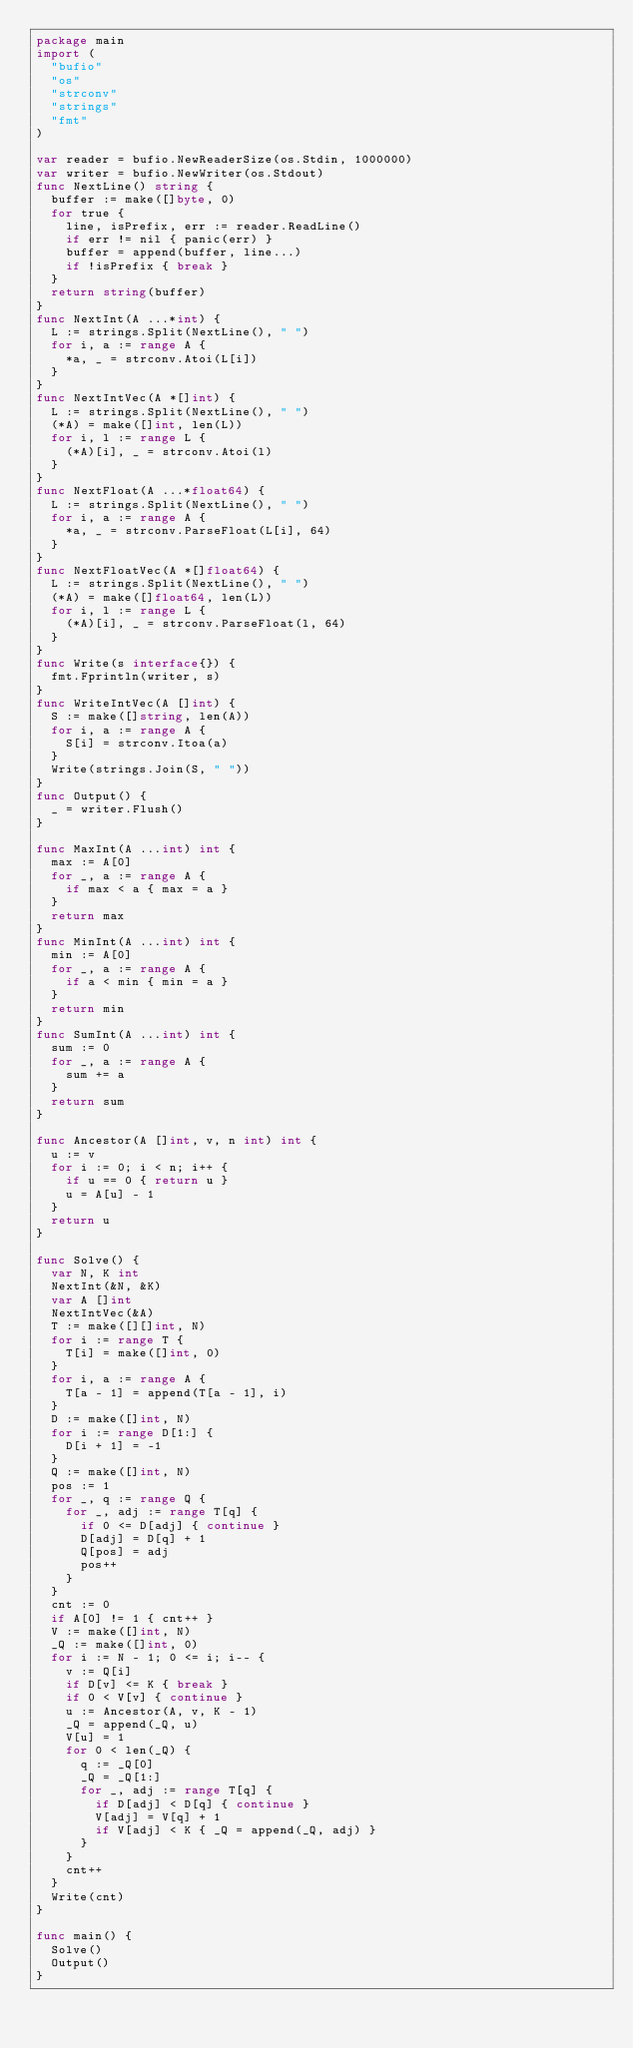<code> <loc_0><loc_0><loc_500><loc_500><_Go_>package main
import (
  "bufio"
  "os"
  "strconv"
  "strings"
  "fmt"
)

var reader = bufio.NewReaderSize(os.Stdin, 1000000)
var writer = bufio.NewWriter(os.Stdout)
func NextLine() string {
  buffer := make([]byte, 0)
  for true {
    line, isPrefix, err := reader.ReadLine()
    if err != nil { panic(err) }
    buffer = append(buffer, line...)
    if !isPrefix { break }
  }
  return string(buffer)
}
func NextInt(A ...*int) {
  L := strings.Split(NextLine(), " ")
  for i, a := range A {
    *a, _ = strconv.Atoi(L[i])
  }
}
func NextIntVec(A *[]int) {
  L := strings.Split(NextLine(), " ")
  (*A) = make([]int, len(L))
  for i, l := range L {
    (*A)[i], _ = strconv.Atoi(l)
  }
}
func NextFloat(A ...*float64) {
  L := strings.Split(NextLine(), " ")
  for i, a := range A {
    *a, _ = strconv.ParseFloat(L[i], 64)
  }
}
func NextFloatVec(A *[]float64) {
  L := strings.Split(NextLine(), " ")
  (*A) = make([]float64, len(L))
  for i, l := range L {
    (*A)[i], _ = strconv.ParseFloat(l, 64)
  }
}
func Write(s interface{}) {
  fmt.Fprintln(writer, s)
}
func WriteIntVec(A []int) {
  S := make([]string, len(A))
  for i, a := range A {
    S[i] = strconv.Itoa(a)
  }
  Write(strings.Join(S, " "))
}
func Output() {
  _ = writer.Flush()
}

func MaxInt(A ...int) int {
  max := A[0]
  for _, a := range A {
    if max < a { max = a }
  }
  return max
}
func MinInt(A ...int) int {
  min := A[0]
  for _, a := range A {
    if a < min { min = a }
  }
  return min
}
func SumInt(A ...int) int {
  sum := 0
  for _, a := range A {
    sum += a
  }
  return sum
}

func Ancestor(A []int, v, n int) int {
  u := v
  for i := 0; i < n; i++ {
    if u == 0 { return u }
    u = A[u] - 1
  }
  return u
}

func Solve() {
  var N, K int
  NextInt(&N, &K)
  var A []int
  NextIntVec(&A)
  T := make([][]int, N)
  for i := range T {
    T[i] = make([]int, 0)
  }
  for i, a := range A {
    T[a - 1] = append(T[a - 1], i)
  }
  D := make([]int, N)
  for i := range D[1:] {
    D[i + 1] = -1
  }
  Q := make([]int, N)
  pos := 1
  for _, q := range Q {
    for _, adj := range T[q] {
      if 0 <= D[adj] { continue }
      D[adj] = D[q] + 1
      Q[pos] = adj
      pos++
    }
  }
  cnt := 0
  if A[0] != 1 { cnt++ }
  V := make([]int, N)
  _Q := make([]int, 0)
  for i := N - 1; 0 <= i; i-- {
    v := Q[i]
    if D[v] <= K { break }
    if 0 < V[v] { continue }
    u := Ancestor(A, v, K - 1)
    _Q = append(_Q, u)
    V[u] = 1
    for 0 < len(_Q) {
      q := _Q[0]
      _Q = _Q[1:]
      for _, adj := range T[q] {
        if D[adj] < D[q] { continue }
        V[adj] = V[q] + 1
        if V[adj] < K { _Q = append(_Q, adj) }
      }
    }
    cnt++
  }
  Write(cnt)
}

func main() {
  Solve()
  Output()
}</code> 